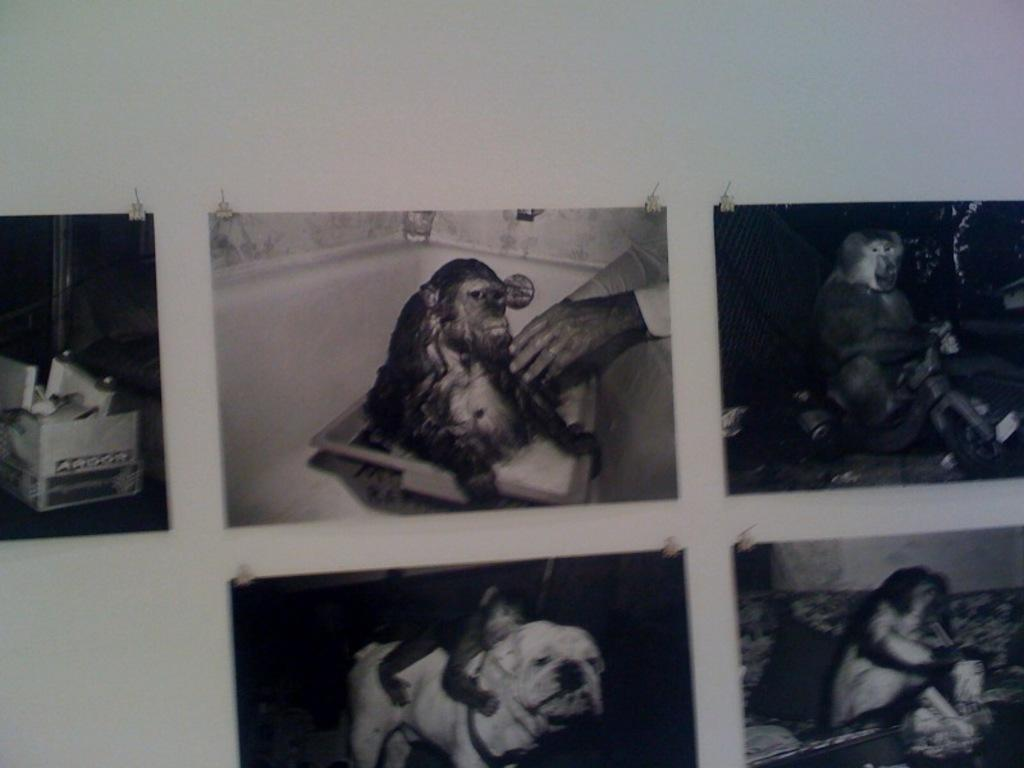What is present on the wall in the image? There are photo frames on the wall. What subjects are depicted in the photo frames? Monkeys, a dog, and a person's hands are depicted in the photo frames. Are there any other objects depicted in the photo frames? Yes, there are other objects depicted in the photo frames. What is the income of the person whose hands are depicted in the photo frames? There is no information about the person's income in the image, as it only shows their hands depicted in the photo frames. 